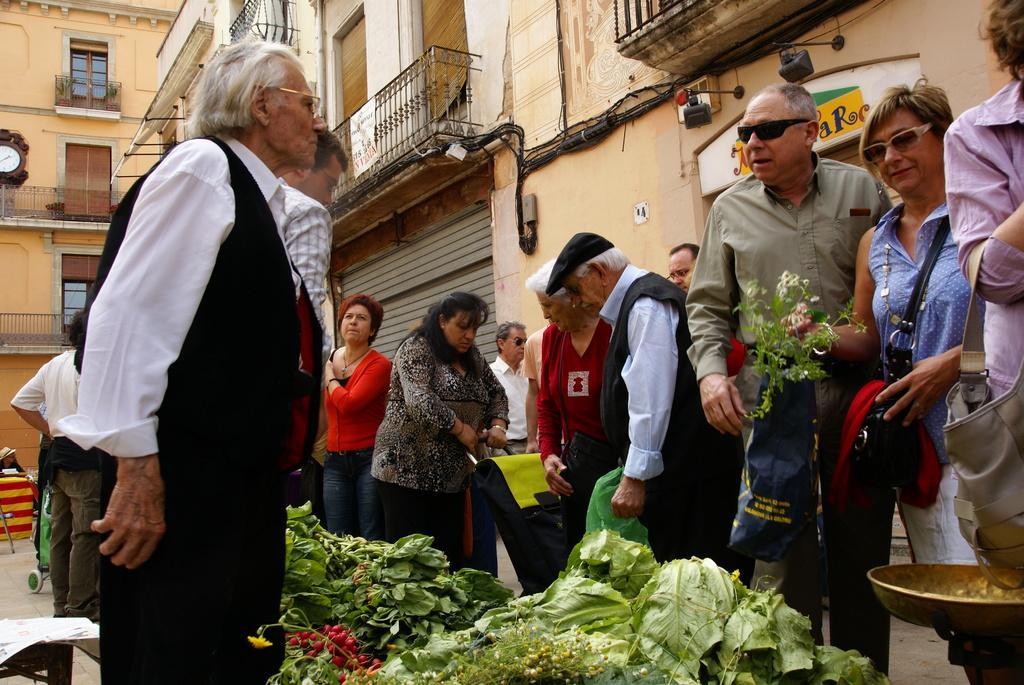Describe this image in one or two sentences. The image is taken on the streets. In the foreground of the picture there are plants, flowers maybe leafy vegetables and people standing, they are holding bags. In the background there are buildings. On the left there is a clock on the building. 